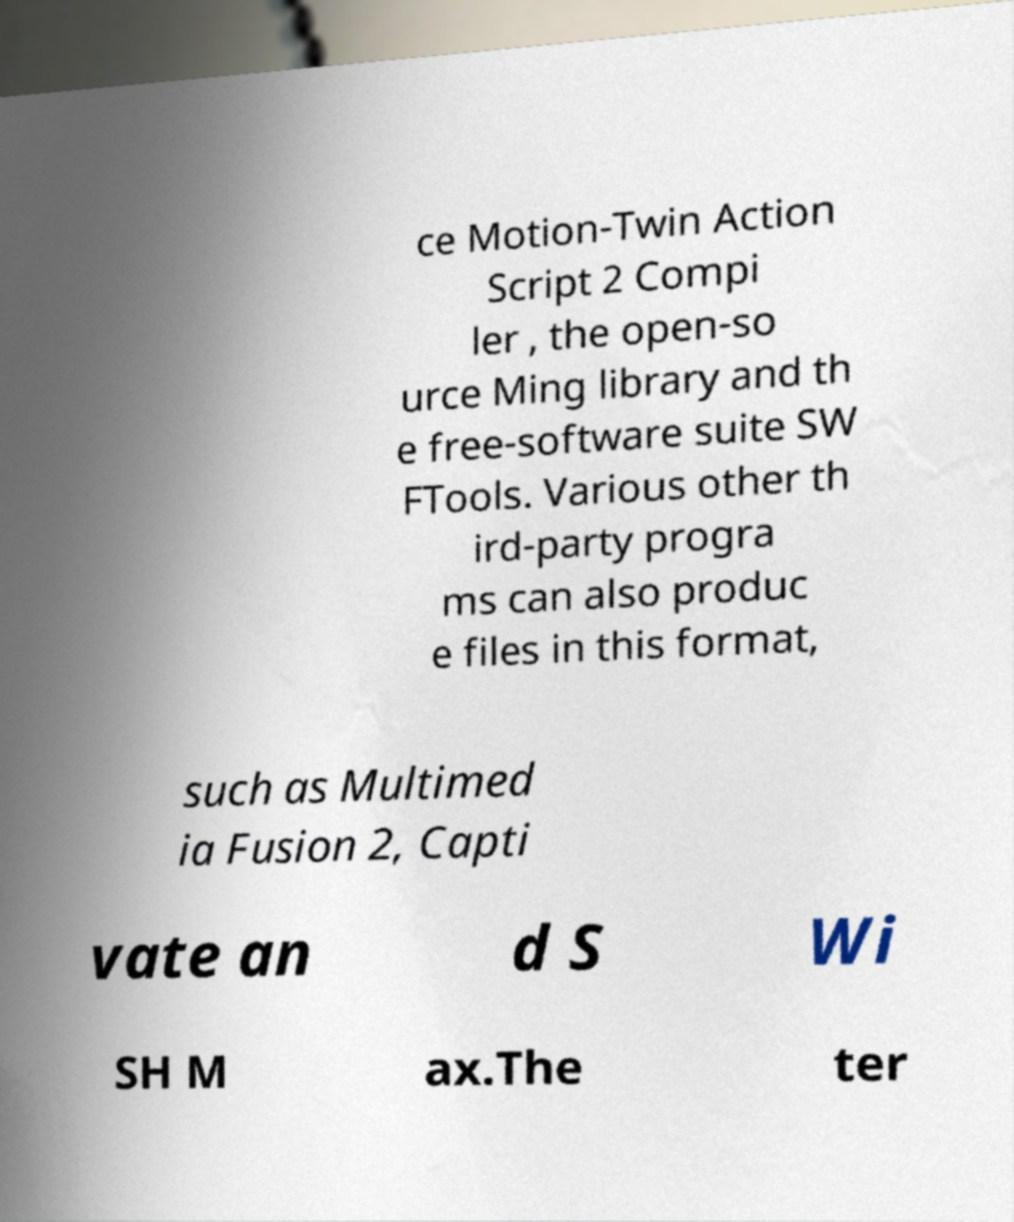Could you assist in decoding the text presented in this image and type it out clearly? ce Motion-Twin Action Script 2 Compi ler , the open-so urce Ming library and th e free-software suite SW FTools. Various other th ird-party progra ms can also produc e files in this format, such as Multimed ia Fusion 2, Capti vate an d S Wi SH M ax.The ter 